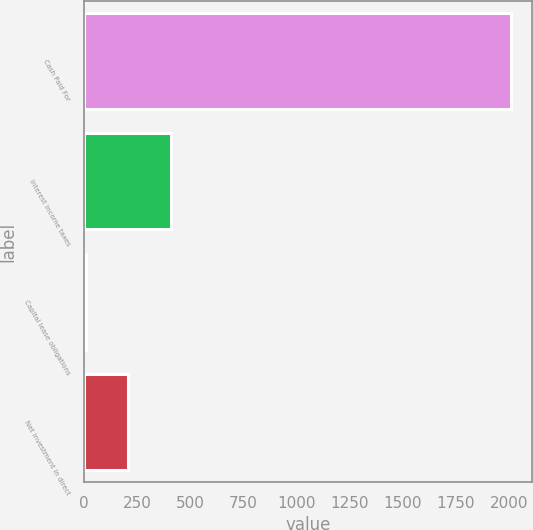Convert chart. <chart><loc_0><loc_0><loc_500><loc_500><bar_chart><fcel>Cash Paid For<fcel>Interest Income taxes<fcel>Capital lease obligations<fcel>Net investment in direct<nl><fcel>2009<fcel>407.4<fcel>7<fcel>207.2<nl></chart> 